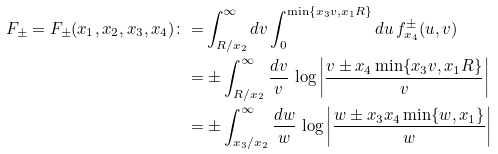Convert formula to latex. <formula><loc_0><loc_0><loc_500><loc_500>F _ { \pm } = F _ { \pm } ( x _ { 1 } , x _ { 2 } , x _ { 3 } , x _ { 4 } ) \colon = & \int _ { R / x _ { 2 } } ^ { \infty } d v \int _ { 0 } ^ { \min \{ x _ { 3 } v , x _ { 1 } R \} } d u \, f ^ { \pm } _ { x _ { 4 } } ( u , v ) \\ = & \pm \int _ { R / x _ { 2 } } ^ { \infty } \frac { d v } { v } \, \log \left | \frac { v \pm x _ { 4 } \min \{ x _ { 3 } v , x _ { 1 } R \} } { v } \right | \\ = & \pm \int _ { x _ { 3 } / x _ { 2 } } ^ { \infty } \frac { d w } { w } \, \log \left | \frac { w \pm x _ { 3 } x _ { 4 } \min \{ w , x _ { 1 } \} } { w } \right |</formula> 